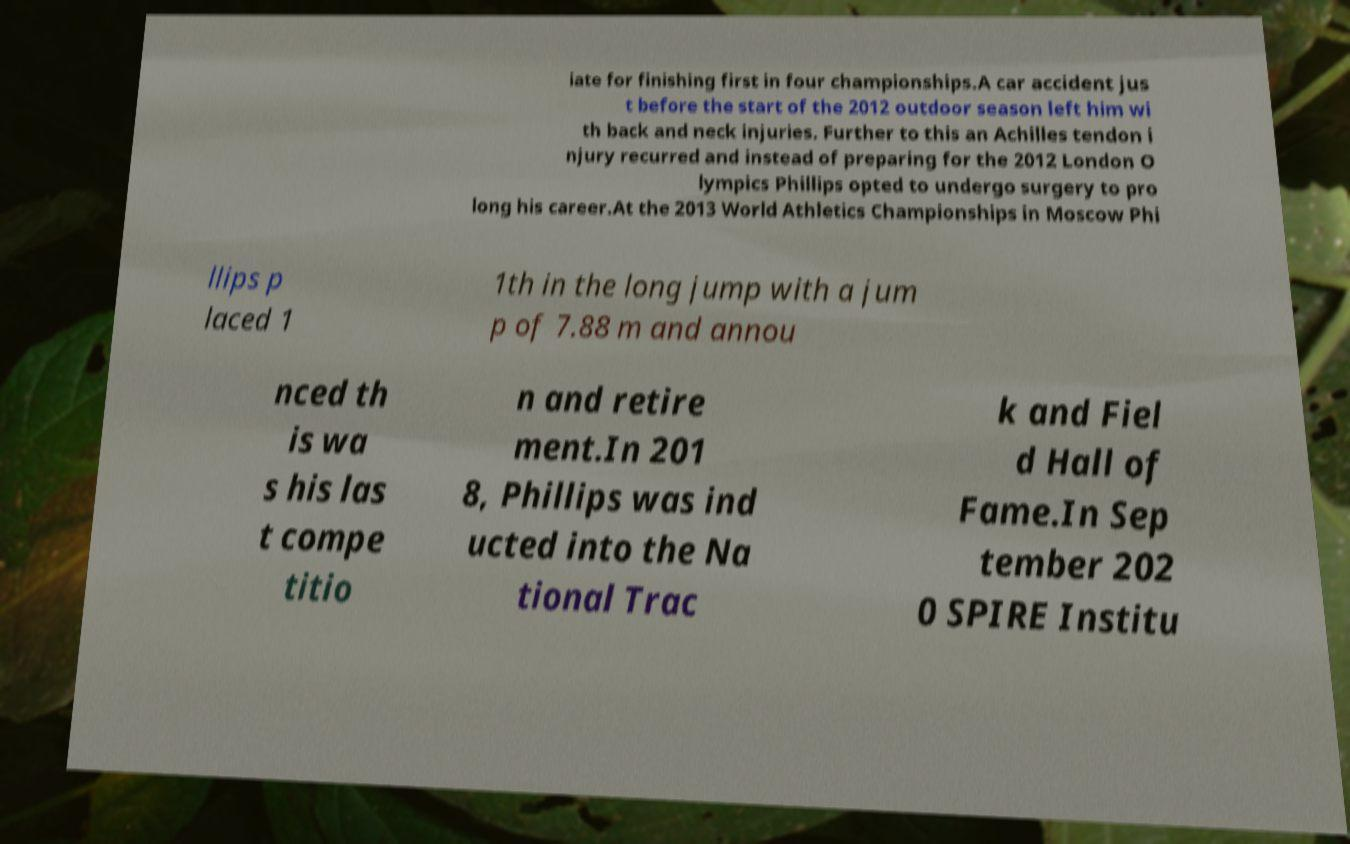Please read and relay the text visible in this image. What does it say? iate for finishing first in four championships.A car accident jus t before the start of the 2012 outdoor season left him wi th back and neck injuries. Further to this an Achilles tendon i njury recurred and instead of preparing for the 2012 London O lympics Phillips opted to undergo surgery to pro long his career.At the 2013 World Athletics Championships in Moscow Phi llips p laced 1 1th in the long jump with a jum p of 7.88 m and annou nced th is wa s his las t compe titio n and retire ment.In 201 8, Phillips was ind ucted into the Na tional Trac k and Fiel d Hall of Fame.In Sep tember 202 0 SPIRE Institu 